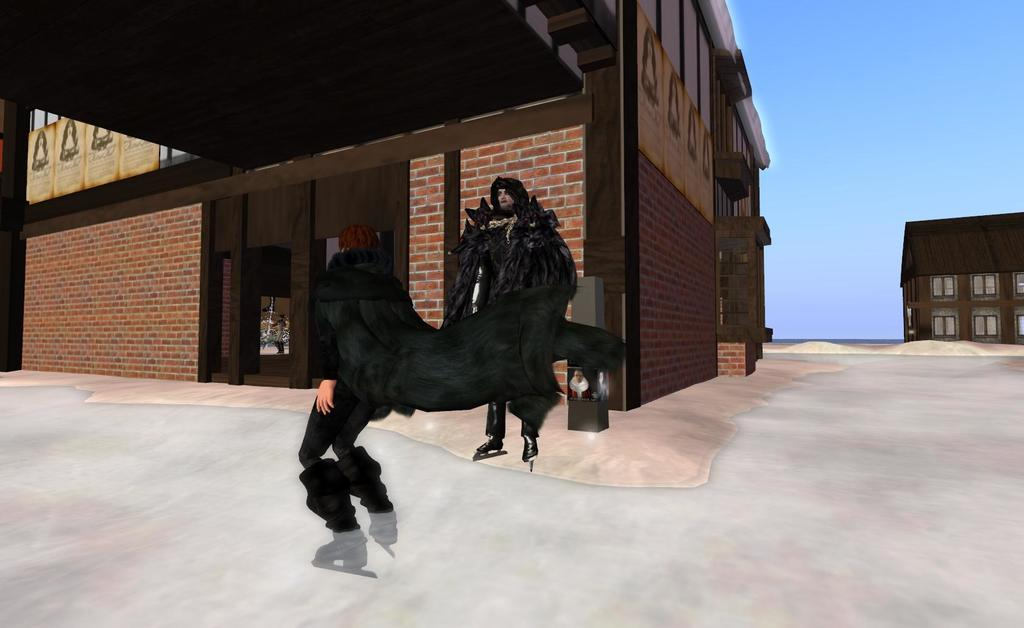What type of image is being described? The image is animated. What can be seen happening on the road in the image? There are people standing on the road in the image. What type of structures are visible in the background of the image? There are buildings in the background of the image. What is visible in the sky in the image? The sky is visible in the background of the image. What type of skirt is the dinosaur wearing in the image? There are no dinosaurs or skirts present in the image; it features people standing on the road with buildings and the sky in the background. 